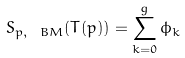Convert formula to latex. <formula><loc_0><loc_0><loc_500><loc_500>S _ { p , \ B M } ( T ( p ) ) = \sum _ { k = 0 } ^ { g } \phi _ { k }</formula> 